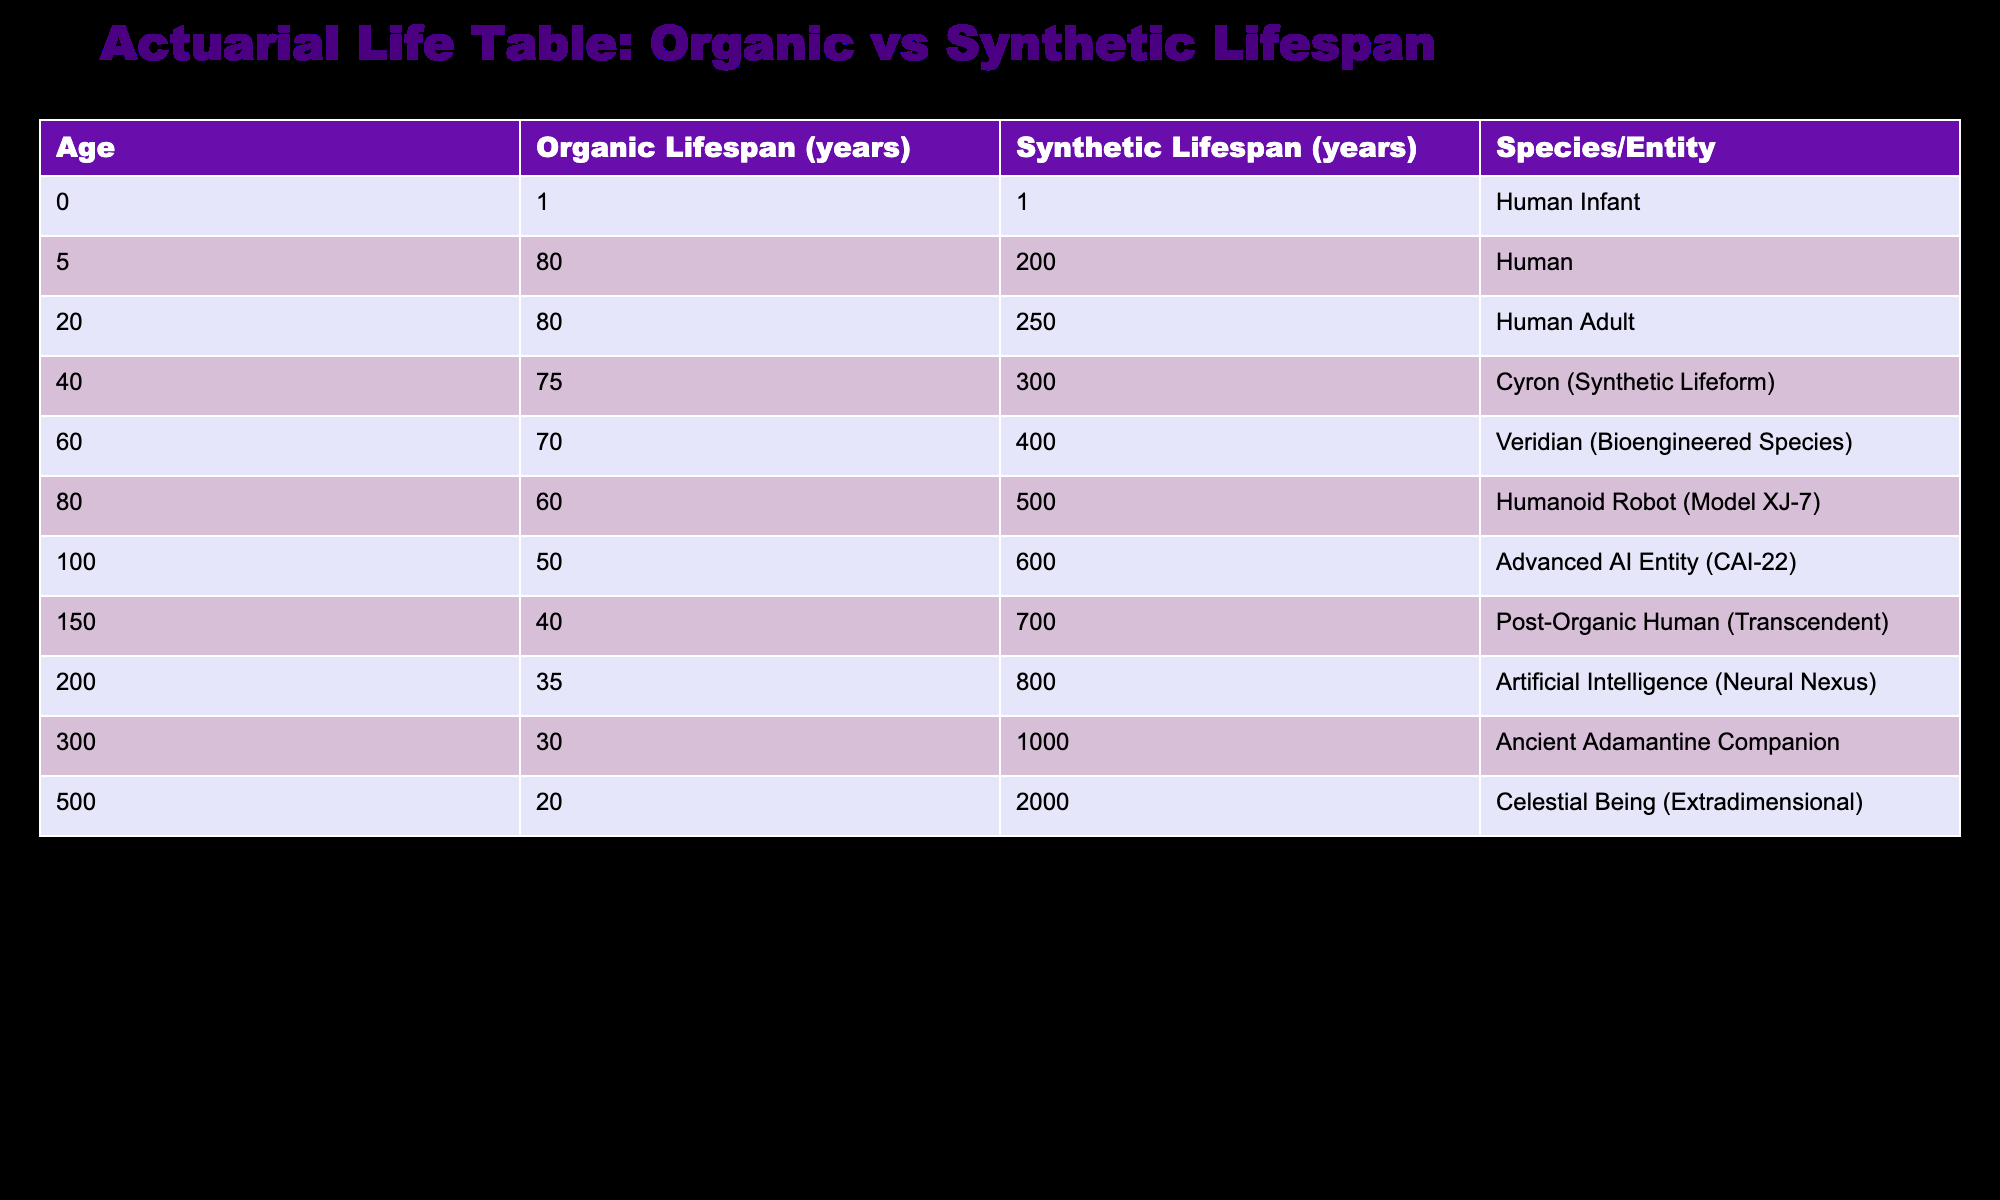What is the lifespan of a Veridian? From the table, the lifespan of a Veridian, which is a bioengineered species, is listed as 400 years.
Answer: 400 years How much longer can a Celestial Being live compared to a Human? The lifespan of a Celestial Being is 2000 years and that of a Human is 80 years. The difference is 2000 - 80 = 1920 years.
Answer: 1920 years Is the average lifespan of synthetic beings greater than that of organic beings? To find the average lifespan of synthetic beings, we sum: 200 + 250 + 300 + 400 + 500 + 600 + 700 + 800 + 1000 + 2000 = 5000 years, divided by 10 data points gives us 500 years. The average lifespan of organic beings can similarly be calculated: 80 + 80 + 75 + 70 + 60 + 50 + 40 + 35 + 30 + 20 = 470 years, and thus the average of 470 / 10 = 47 years. Since 500 > 47, the statement is true.
Answer: Yes Which species has the highest lifespan in the table? The longest lifespan listed in the table is for the Celestial Being (Extradimensional) at 2000 years.
Answer: Celestial Being (Extradimensional) If we combine the lifespans of all Humanoids and compare it with all Synthetic beings, do Synthetics have a significantly higher lifespan? The total lifespan of Humanoids is 80 + 80 + 75 + 70 + 60 + 50 + 40 + 35 + 30 + 20 = 470 years. The total lifespan of Synthetic beings is 200 + 250 + 300 + 400 + 500 + 600 + 700 + 800 + 1000 + 2000 = 5000 years. The significant difference is 5000 - 470 = 4530 years, which shows Synthetics have a much higher lifespan.
Answer: Yes What is the median lifespan of organic life forms? To find the median, we need to organize the lifespans of organic life forms: 20, 30, 35, 40, 50, 60, 70, 75, 80, 80. With 10 data points, the median will be the average of the 5th and 6th values: (50 + 60) / 2 = 55 years.
Answer: 55 years Is the lifespan of Advanced AI Entity (CAI-22) greater than the average lifespan of Humans across different stages? The lifespan of an Advanced AI Entity (CAI-22) is 600 years. The average lifespan of Humans (infant, adult, and elderly) can be calculated as (1 + 80 + 80 + 75 + 70 + 60 + 50 + 40 + 35 + 30) / 10 = 42.2 years. Since 600 is greater than 42.2, the statement is true.
Answer: Yes What is the total difference in lifespan between the youngest and oldest species listed in the table? The youngest species is the Human Infant with a lifespan of 1 year, and the oldest is the Celestial Being with 2000 years. Their difference is 2000 - 1 = 1999 years.
Answer: 1999 years 